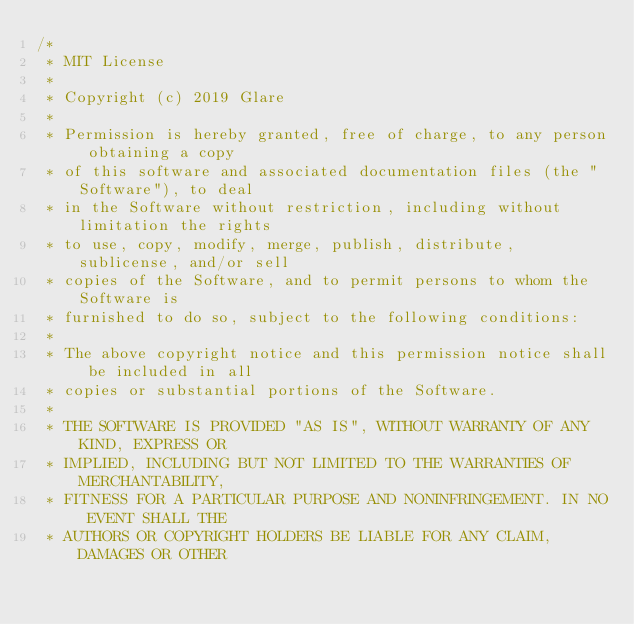<code> <loc_0><loc_0><loc_500><loc_500><_Kotlin_>/*
 * MIT License
 *
 * Copyright (c) 2019 Glare
 *
 * Permission is hereby granted, free of charge, to any person obtaining a copy
 * of this software and associated documentation files (the "Software"), to deal
 * in the Software without restriction, including without limitation the rights
 * to use, copy, modify, merge, publish, distribute, sublicense, and/or sell
 * copies of the Software, and to permit persons to whom the Software is
 * furnished to do so, subject to the following conditions:
 *
 * The above copyright notice and this permission notice shall be included in all
 * copies or substantial portions of the Software.
 *
 * THE SOFTWARE IS PROVIDED "AS IS", WITHOUT WARRANTY OF ANY KIND, EXPRESS OR
 * IMPLIED, INCLUDING BUT NOT LIMITED TO THE WARRANTIES OF MERCHANTABILITY,
 * FITNESS FOR A PARTICULAR PURPOSE AND NONINFRINGEMENT. IN NO EVENT SHALL THE
 * AUTHORS OR COPYRIGHT HOLDERS BE LIABLE FOR ANY CLAIM, DAMAGES OR OTHER</code> 